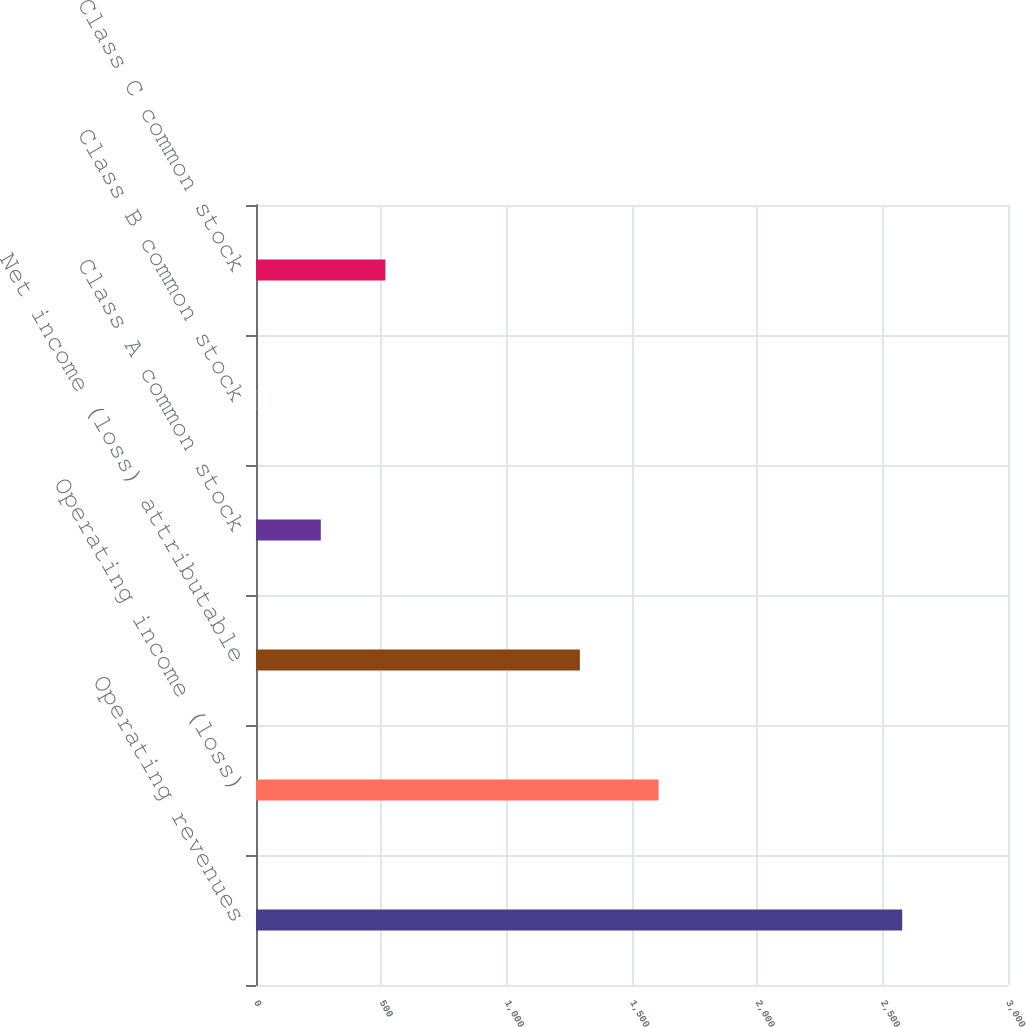<chart> <loc_0><loc_0><loc_500><loc_500><bar_chart><fcel>Operating revenues<fcel>Operating income (loss)<fcel>Net income (loss) attributable<fcel>Class A common stock<fcel>Class B common stock<fcel>Class C common stock<nl><fcel>2578<fcel>1606<fcel>1292<fcel>258.54<fcel>0.82<fcel>516.26<nl></chart> 